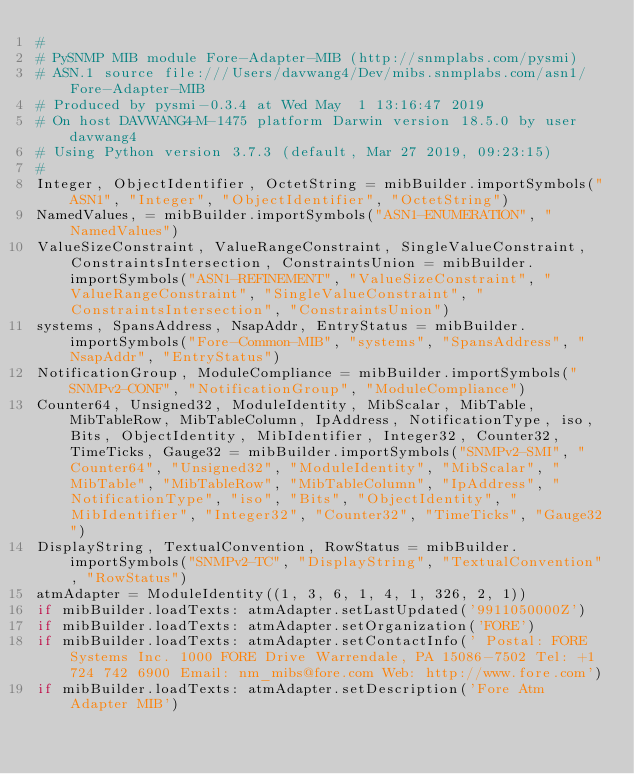<code> <loc_0><loc_0><loc_500><loc_500><_Python_>#
# PySNMP MIB module Fore-Adapter-MIB (http://snmplabs.com/pysmi)
# ASN.1 source file:///Users/davwang4/Dev/mibs.snmplabs.com/asn1/Fore-Adapter-MIB
# Produced by pysmi-0.3.4 at Wed May  1 13:16:47 2019
# On host DAVWANG4-M-1475 platform Darwin version 18.5.0 by user davwang4
# Using Python version 3.7.3 (default, Mar 27 2019, 09:23:15) 
#
Integer, ObjectIdentifier, OctetString = mibBuilder.importSymbols("ASN1", "Integer", "ObjectIdentifier", "OctetString")
NamedValues, = mibBuilder.importSymbols("ASN1-ENUMERATION", "NamedValues")
ValueSizeConstraint, ValueRangeConstraint, SingleValueConstraint, ConstraintsIntersection, ConstraintsUnion = mibBuilder.importSymbols("ASN1-REFINEMENT", "ValueSizeConstraint", "ValueRangeConstraint", "SingleValueConstraint", "ConstraintsIntersection", "ConstraintsUnion")
systems, SpansAddress, NsapAddr, EntryStatus = mibBuilder.importSymbols("Fore-Common-MIB", "systems", "SpansAddress", "NsapAddr", "EntryStatus")
NotificationGroup, ModuleCompliance = mibBuilder.importSymbols("SNMPv2-CONF", "NotificationGroup", "ModuleCompliance")
Counter64, Unsigned32, ModuleIdentity, MibScalar, MibTable, MibTableRow, MibTableColumn, IpAddress, NotificationType, iso, Bits, ObjectIdentity, MibIdentifier, Integer32, Counter32, TimeTicks, Gauge32 = mibBuilder.importSymbols("SNMPv2-SMI", "Counter64", "Unsigned32", "ModuleIdentity", "MibScalar", "MibTable", "MibTableRow", "MibTableColumn", "IpAddress", "NotificationType", "iso", "Bits", "ObjectIdentity", "MibIdentifier", "Integer32", "Counter32", "TimeTicks", "Gauge32")
DisplayString, TextualConvention, RowStatus = mibBuilder.importSymbols("SNMPv2-TC", "DisplayString", "TextualConvention", "RowStatus")
atmAdapter = ModuleIdentity((1, 3, 6, 1, 4, 1, 326, 2, 1))
if mibBuilder.loadTexts: atmAdapter.setLastUpdated('9911050000Z')
if mibBuilder.loadTexts: atmAdapter.setOrganization('FORE')
if mibBuilder.loadTexts: atmAdapter.setContactInfo(' Postal: FORE Systems Inc. 1000 FORE Drive Warrendale, PA 15086-7502 Tel: +1 724 742 6900 Email: nm_mibs@fore.com Web: http://www.fore.com')
if mibBuilder.loadTexts: atmAdapter.setDescription('Fore Atm Adapter MIB')</code> 